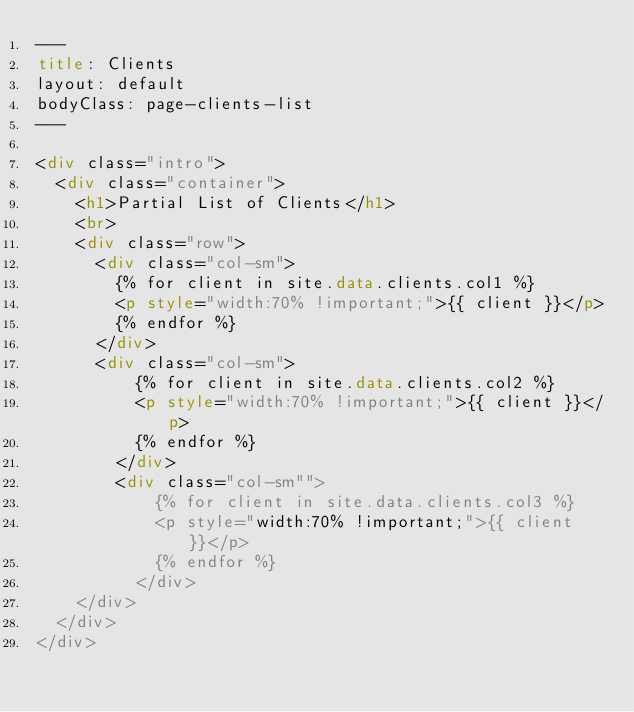<code> <loc_0><loc_0><loc_500><loc_500><_HTML_>---
title: Clients
layout: default
bodyClass: page-clients-list
---

<div class="intro">
  <div class="container">
    <h1>Partial List of Clients</h1>
    <br>
    <div class="row">
      <div class="col-sm">
        {% for client in site.data.clients.col1 %}
        <p style="width:70% !important;">{{ client }}</p>
        {% endfor %}
      </div>
      <div class="col-sm">
          {% for client in site.data.clients.col2 %}
          <p style="width:70% !important;">{{ client }}</p>
          {% endfor %}
        </div>
        <div class="col-sm"">
            {% for client in site.data.clients.col3 %}
            <p style="width:70% !important;">{{ client }}</p>
            {% endfor %}
          </div>
    </div>
  </div>
</div></code> 